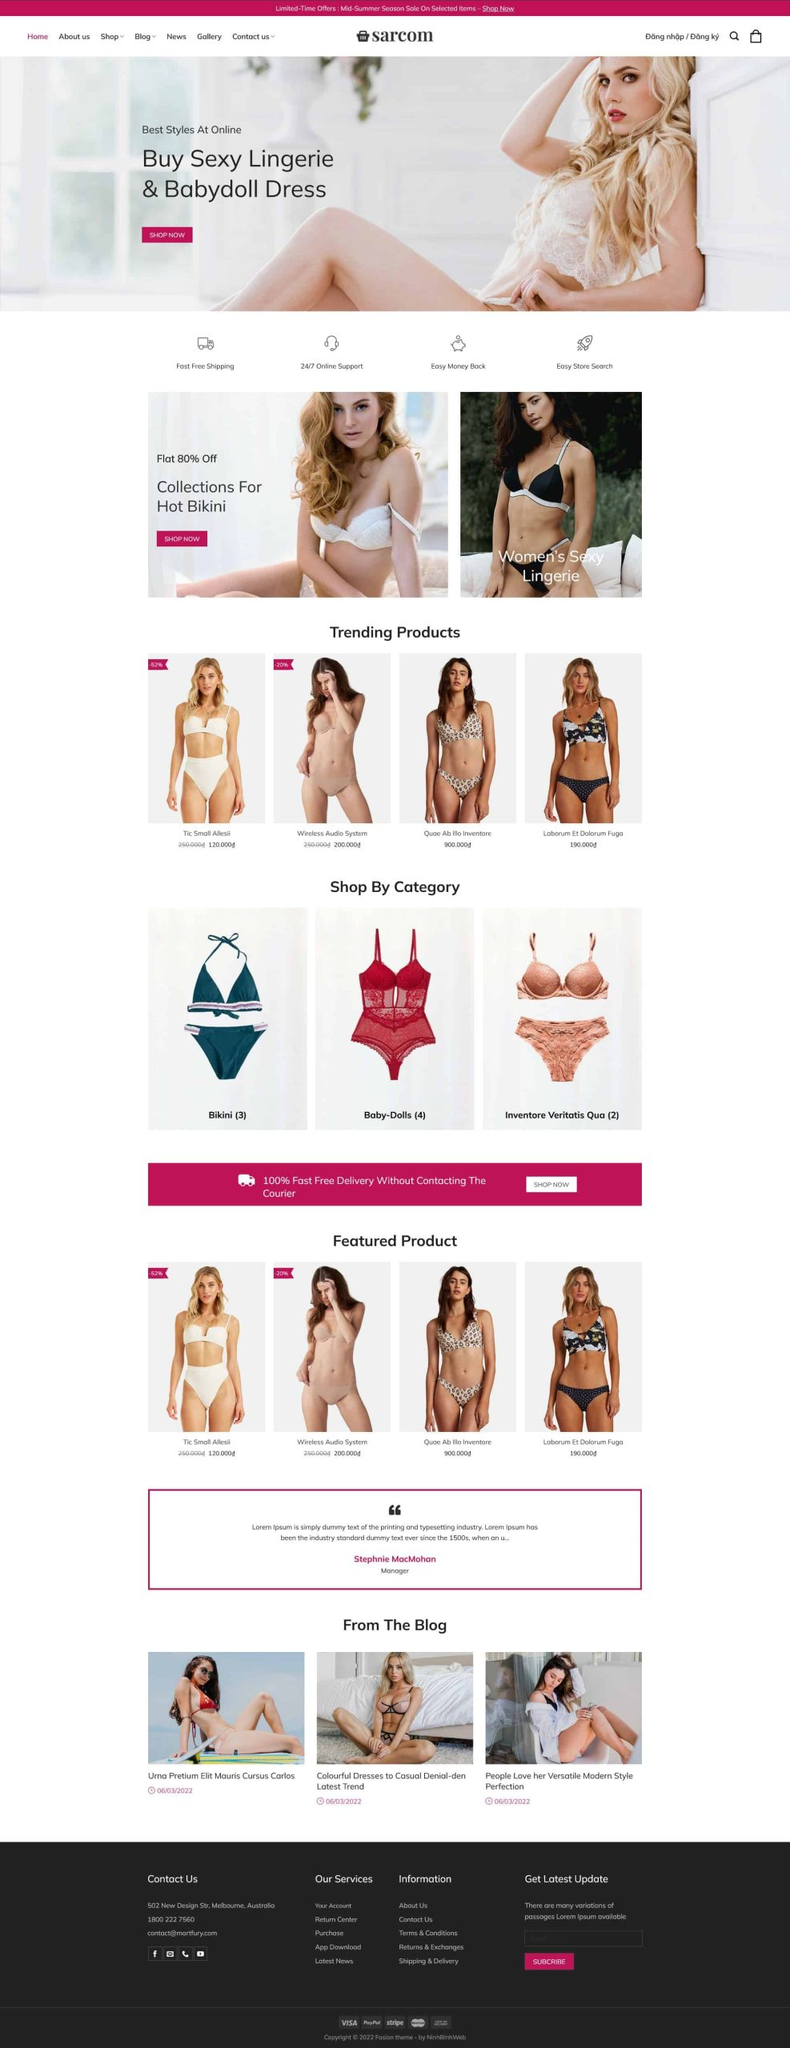Liệt kê 5 ngành nghề, lĩnh vực phù hợp với website này, phân cách các màu sắc bằng dấu phẩy. Chỉ trả về kết quả, phân cách bằng dấy phẩy
 Thời trang, Thương mại điện tử, Bán lẻ, Tiếp thị số, Blog thời trang 